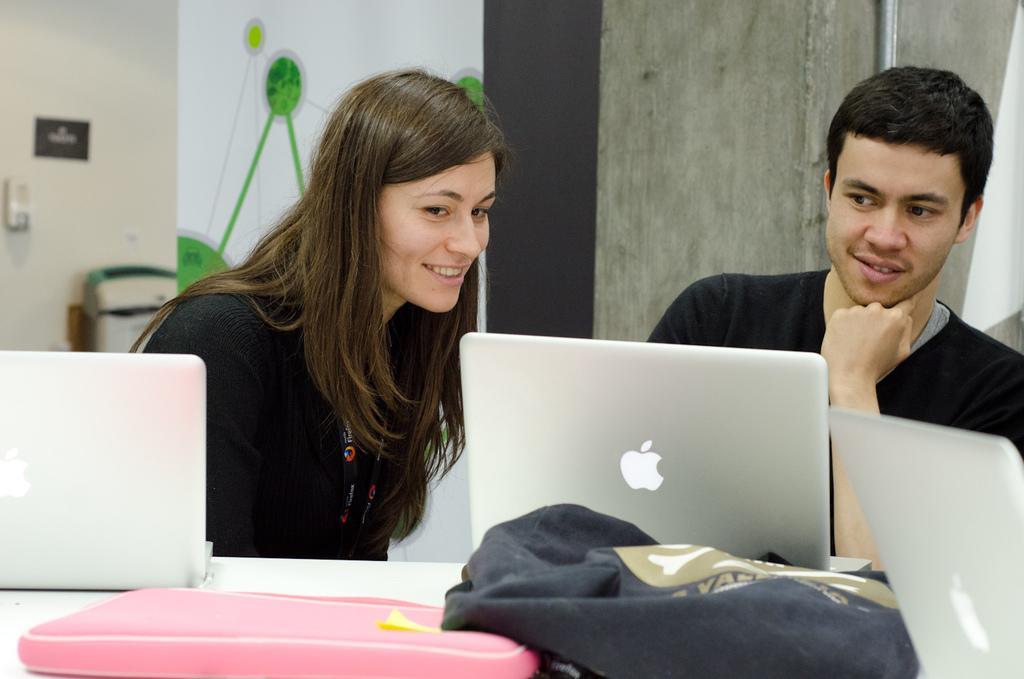Could you give a brief overview of what you see in this image? In the foreground of this image, there are two bags, three laptops on the table and a woman and a man sitting in front of it. In the background, there are walls and few objects near the wall. 